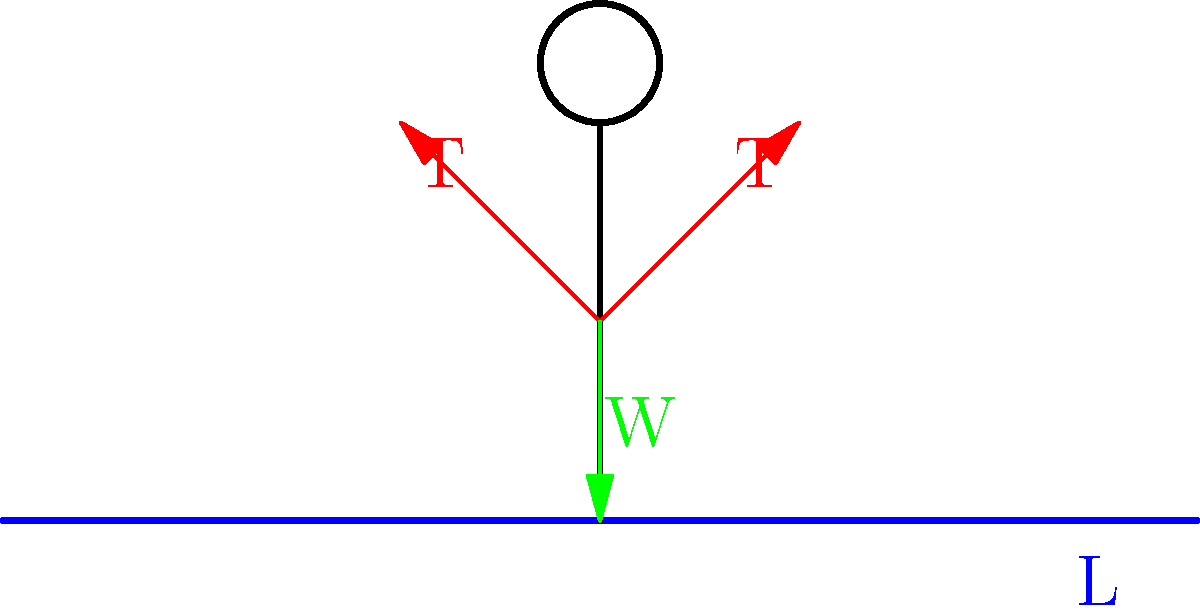As the circus manager, you're assessing the safety of a new tightrope act. The wire is 20 meters long and sags 0.5 meters at its center when a 70 kg performer stands on it. Assuming the wire forms a parabola, what is the tension in the wire? (Use g = 9.8 m/s²) Let's approach this step-by-step:

1) First, we need to understand that the shape of the wire is approximately parabolic. The equation of a parabola with vertex at (0, -h) is:

   $$y = ax^2 - h$$

   where h is the sag (0.5 m) and a is a constant we need to determine.

2) We know that at the end of the wire (L/2 = 10 m), y = 0. So:

   $$0 = a(10^2) - 0.5$$
   $$a = \frac{0.5}{100} = 0.005$$

3) The tension in the wire is related to the slope of the wire. The slope at any point is given by:

   $$\frac{dy}{dx} = 2ax$$

4) At the end of the wire (x = 10), the slope is:

   $$\frac{dy}{dx} = 2(0.005)(10) = 0.1$$

5) The tension (T) is related to the weight (W) and the slope by:

   $$T = \frac{W}{\sin(\theta)} \approx \frac{W}{\tan(\theta)} = \frac{W}{\frac{dy}{dx}}$$

   when the angle is small.

6) The weight W = 70 kg * 9.8 m/s² = 686 N

7) Therefore, the tension is:

   $$T = \frac{686}{0.1} = 6860 \text{ N}$$
Answer: 6860 N 